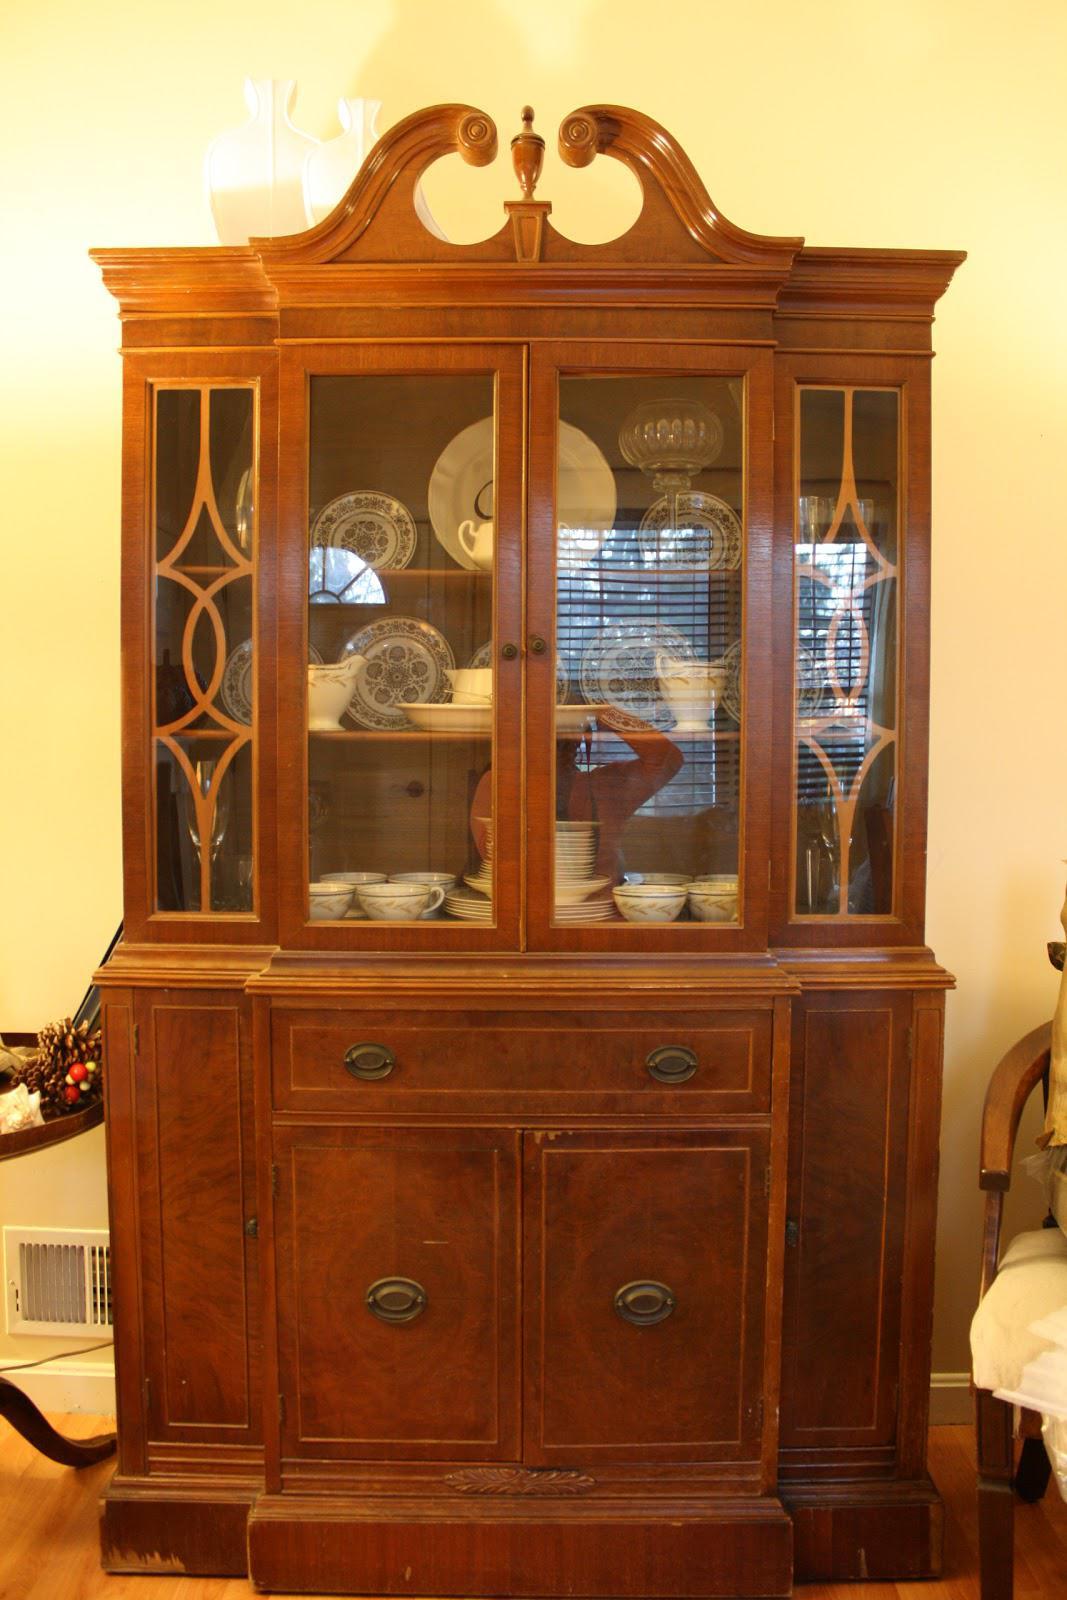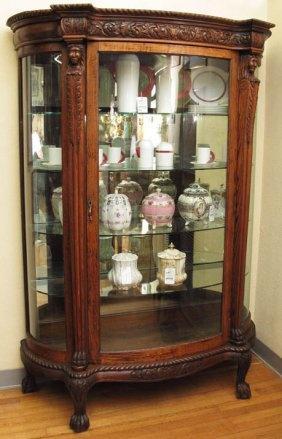The first image is the image on the left, the second image is the image on the right. Evaluate the accuracy of this statement regarding the images: "All china cabinets have solid doors and drawers at the bottom and glass fronted doors on top.". Is it true? Answer yes or no. No. The first image is the image on the left, the second image is the image on the right. For the images displayed, is the sentence "There is a plant resting on top of one of the furniture." factually correct? Answer yes or no. No. 